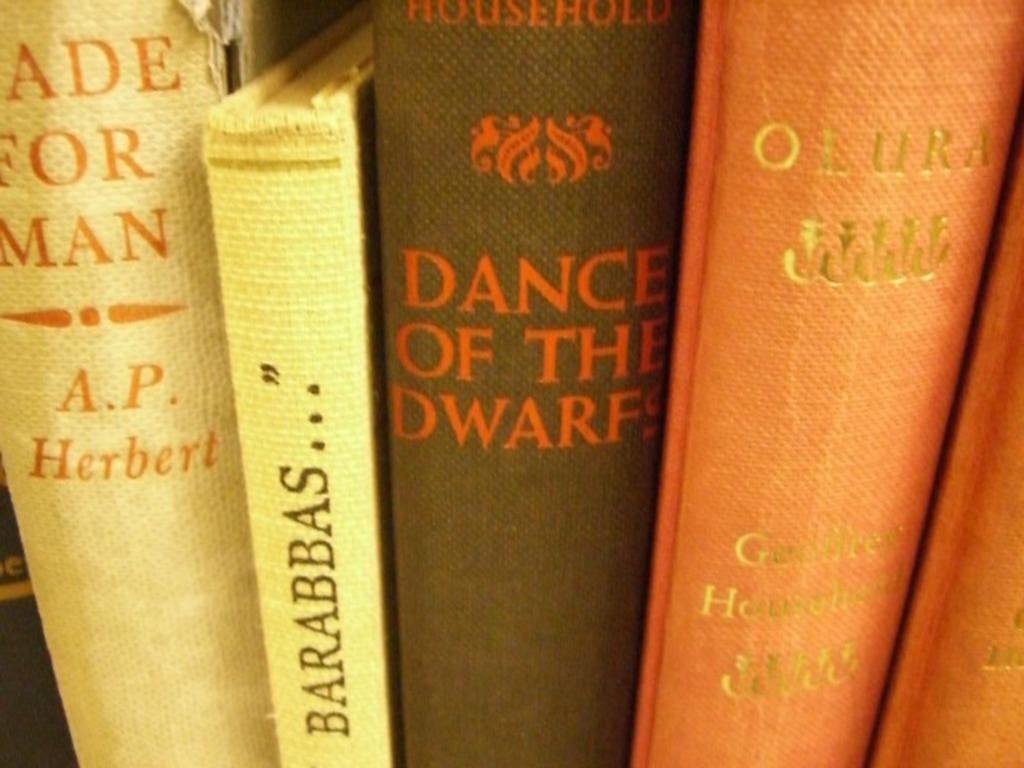What type of objects are present in the image? There are books with text in the image. Can you describe the book in the middle of the image? The book in the middle of the image has both text and an image. What type of plants can be seen growing in the shop in the image? There is no shop or plants present in the image; it only features books with text and an image. 